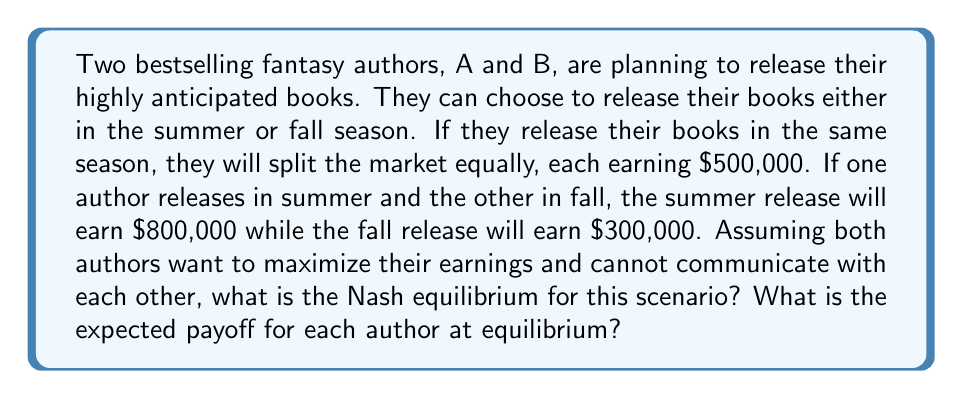What is the answer to this math problem? To solve this problem, we need to analyze the scenario using game theory principles, specifically the concept of Nash equilibrium. Let's break it down step-by-step:

1. First, let's create a payoff matrix for the scenario:

[asy]
unitsize(1cm);

draw((0,0)--(6,0)--(6,6)--(0,6)--cycle);
draw((0,3)--(6,3));
draw((3,0)--(3,6));

label("Author B", (1.5,6.5));
label("Summer", (1.5,5.5));
label("Fall", (1.5,1.5));

label("Author A", (-1.5,3), W);
label("Summer", (-0.5,4.5), W);
label("Fall", (-0.5,1.5), W);

label("(500, 500)", (1.5,4.5));
label("(800, 300)", (4.5,4.5));
label("(300, 800)", (1.5,1.5));
label("(500, 500)", (4.5,1.5));
[/asy]

2. To find the Nash equilibrium, we need to identify strategies where neither author can unilaterally improve their payoff by changing their strategy.

3. Let's examine each author's best responses:
   - If A chooses Summer, B's best response is Fall ($800,000 > $500,000)
   - If A chooses Fall, B's best response is Summer ($800,000 > $500,000)
   - If B chooses Summer, A's best response is Fall ($800,000 > $500,000)
   - If B chooses Fall, A's best response is Summer ($800,000 > $500,000)

4. We can see that there is no pure strategy Nash equilibrium, as there's no cell in the matrix where both authors are playing their best responses simultaneously.

5. In this case, we need to look for a mixed strategy Nash equilibrium. Let's define:
   $p$ = probability of Author A choosing Summer
   $q$ = probability of Author B choosing Summer

6. For a mixed strategy to be optimal, the expected payoff for each pure strategy must be equal:

   For Author A:
   $500q + 800(1-q) = 300q + 500(1-q)$
   $500q + 800 - 800q = 300q + 500 - 500q$
   $-300q + 800 = -200q + 500$
   $-100q = -300$
   $q = \frac{3}{10} = 0.3$

   For Author B:
   $500p + 800(1-p) = 300p + 500(1-p)$
   $500p + 800 - 800p = 300p + 500 - 500p$
   $-300p + 800 = -200p + 500$
   $-100p = -300$
   $p = \frac{3}{10} = 0.3$

7. The Nash equilibrium is for both authors to choose Summer with probability 0.3 and Fall with probability 0.7.

8. To calculate the expected payoff at equilibrium:
   $E(\text{payoff}) = 0.3 \cdot 0.3 \cdot 500 + 0.3 \cdot 0.7 \cdot 300 + 0.7 \cdot 0.3 \cdot 800 + 0.7 \cdot 0.7 \cdot 500$
   $= 45 + 63 + 168 + 245 = 521$

Therefore, the expected payoff for each author at equilibrium is $521,000.
Answer: The Nash equilibrium is a mixed strategy where both authors choose Summer with probability 0.3 and Fall with probability 0.7. The expected payoff for each author at equilibrium is $521,000. 